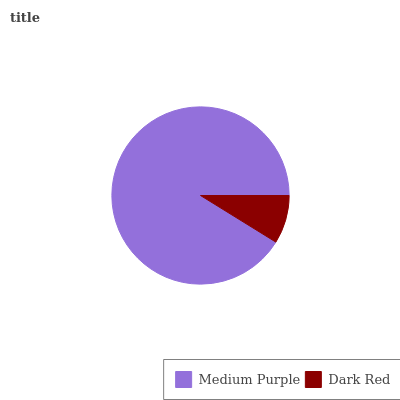Is Dark Red the minimum?
Answer yes or no. Yes. Is Medium Purple the maximum?
Answer yes or no. Yes. Is Dark Red the maximum?
Answer yes or no. No. Is Medium Purple greater than Dark Red?
Answer yes or no. Yes. Is Dark Red less than Medium Purple?
Answer yes or no. Yes. Is Dark Red greater than Medium Purple?
Answer yes or no. No. Is Medium Purple less than Dark Red?
Answer yes or no. No. Is Medium Purple the high median?
Answer yes or no. Yes. Is Dark Red the low median?
Answer yes or no. Yes. Is Dark Red the high median?
Answer yes or no. No. Is Medium Purple the low median?
Answer yes or no. No. 